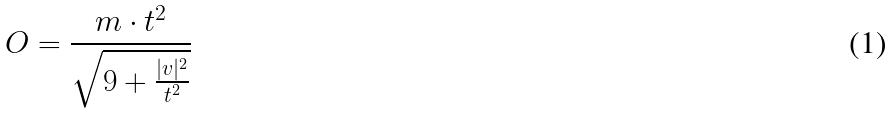Convert formula to latex. <formula><loc_0><loc_0><loc_500><loc_500>O = \frac { m \cdot t ^ { 2 } } { \sqrt { 9 + \frac { | v | ^ { 2 } } { t ^ { 2 } } } }</formula> 